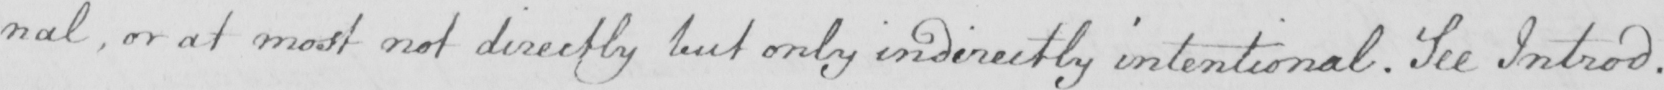Can you read and transcribe this handwriting? :nal, or at most not directly but only indirectly intentional. See Introd. 